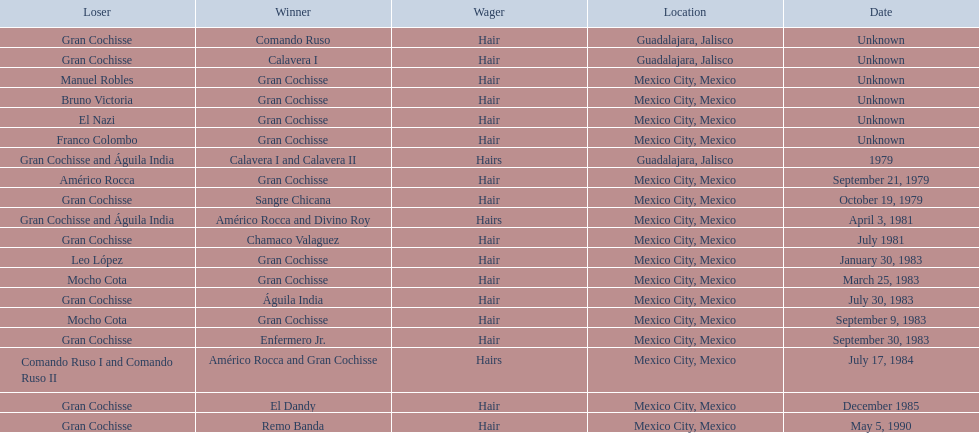When was gran chochisse first match that had a full date on record? September 21, 1979. 